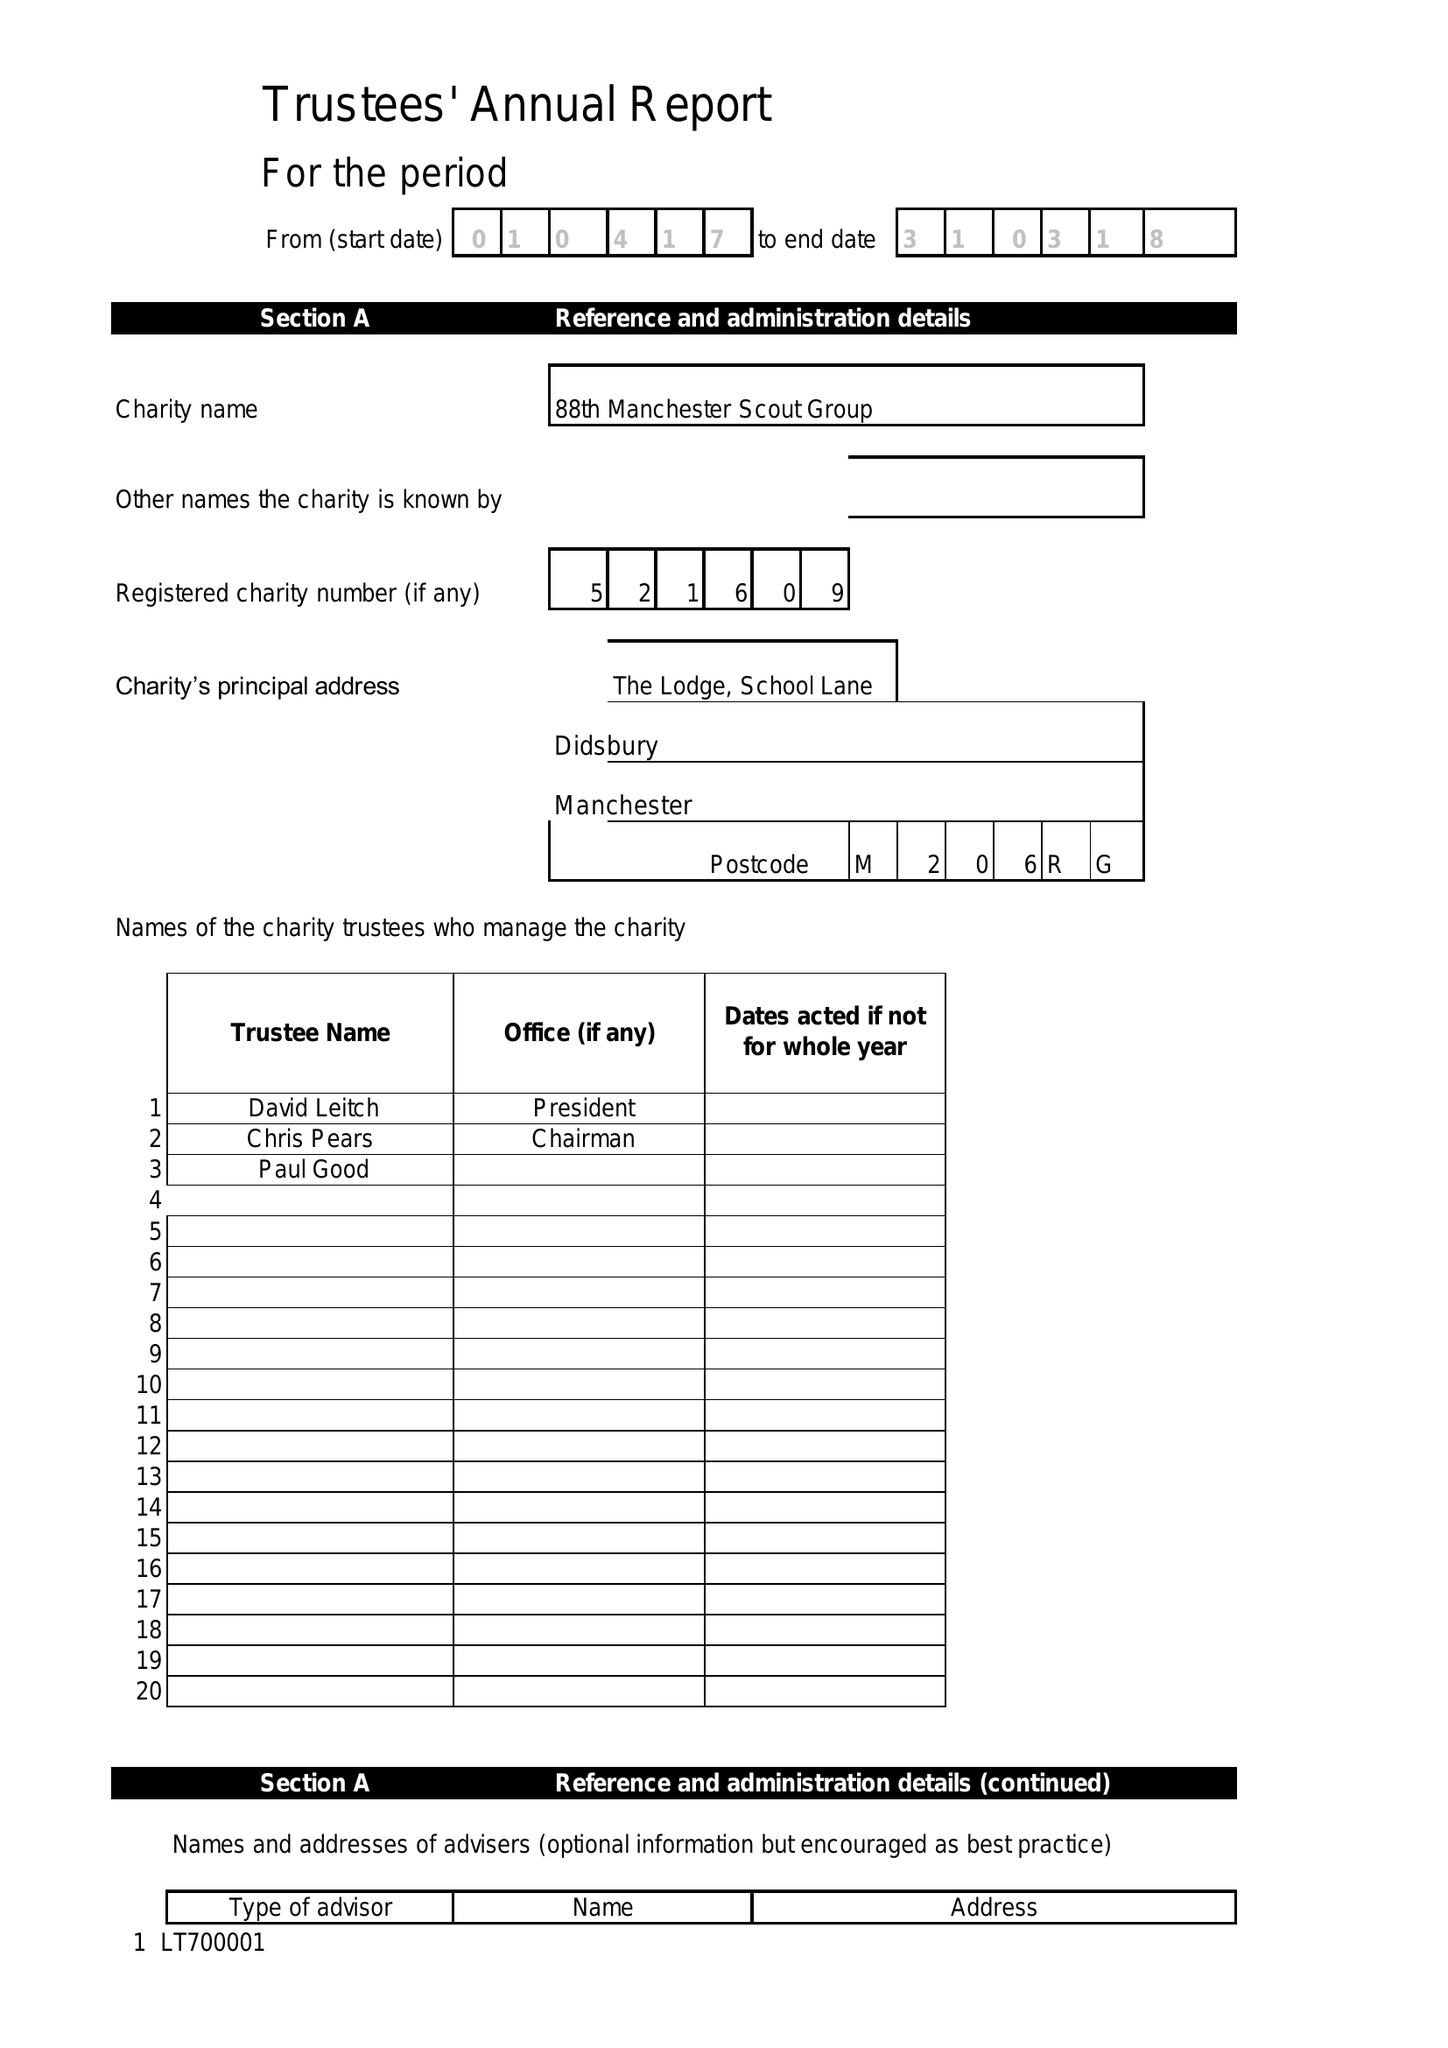What is the value for the spending_annually_in_british_pounds?
Answer the question using a single word or phrase. 22860.00 